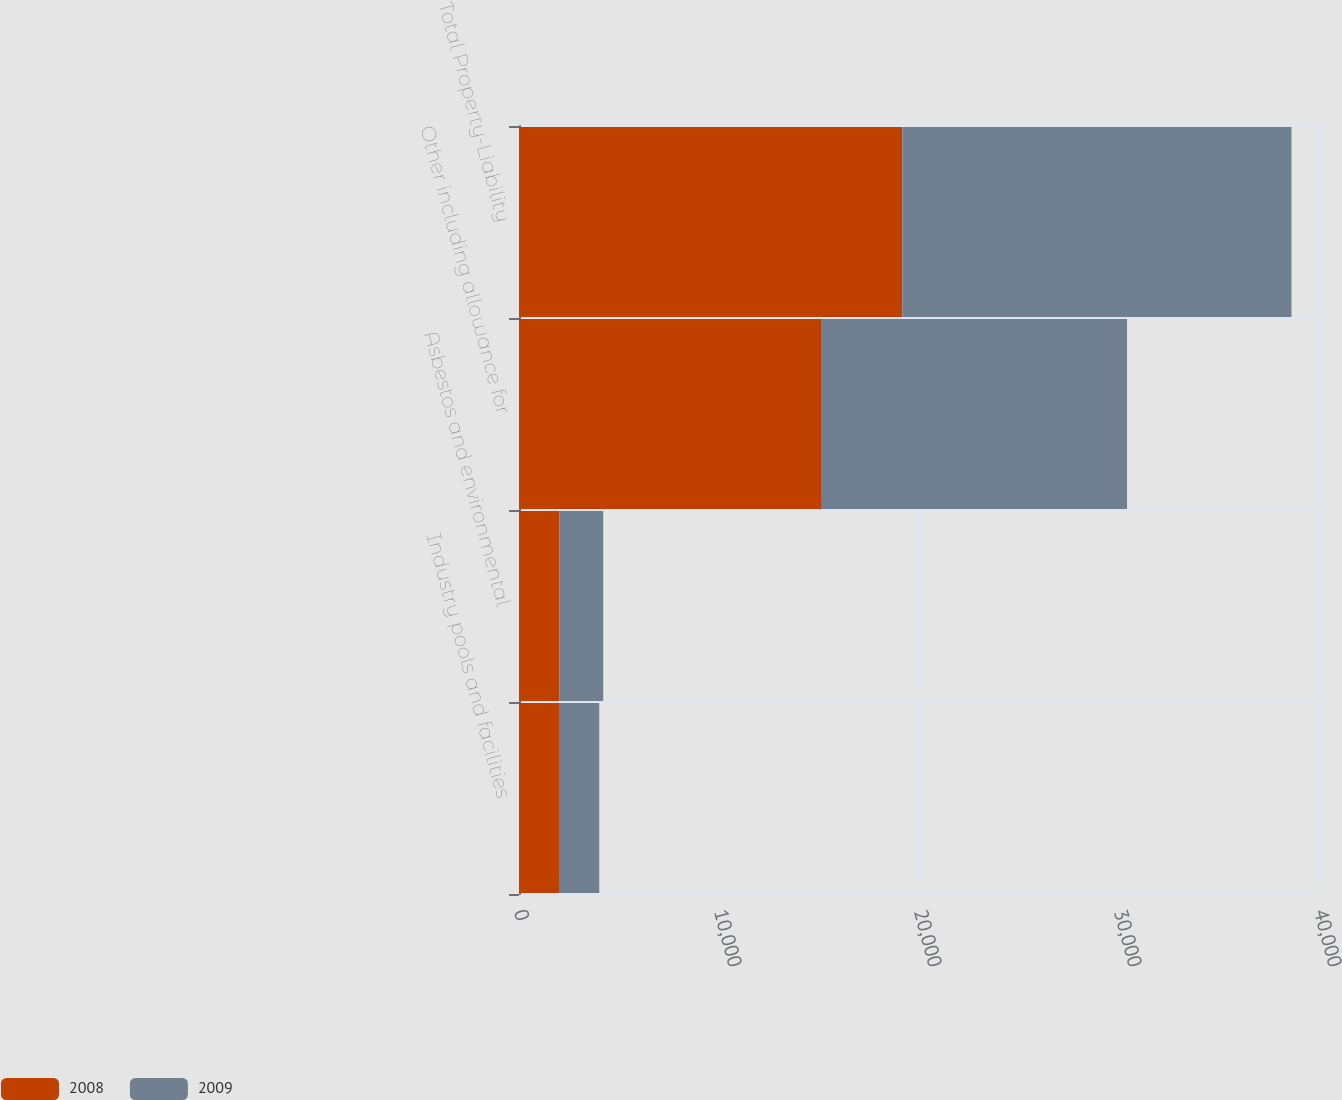Convert chart. <chart><loc_0><loc_0><loc_500><loc_500><stacked_bar_chart><ecel><fcel>Industry pools and facilities<fcel>Asbestos and environmental<fcel>Other including allowance for<fcel>Total Property-Liability<nl><fcel>2008<fcel>2000<fcel>2027<fcel>15140<fcel>19167<nl><fcel>2009<fcel>2012<fcel>2183<fcel>15261<fcel>19456<nl></chart> 